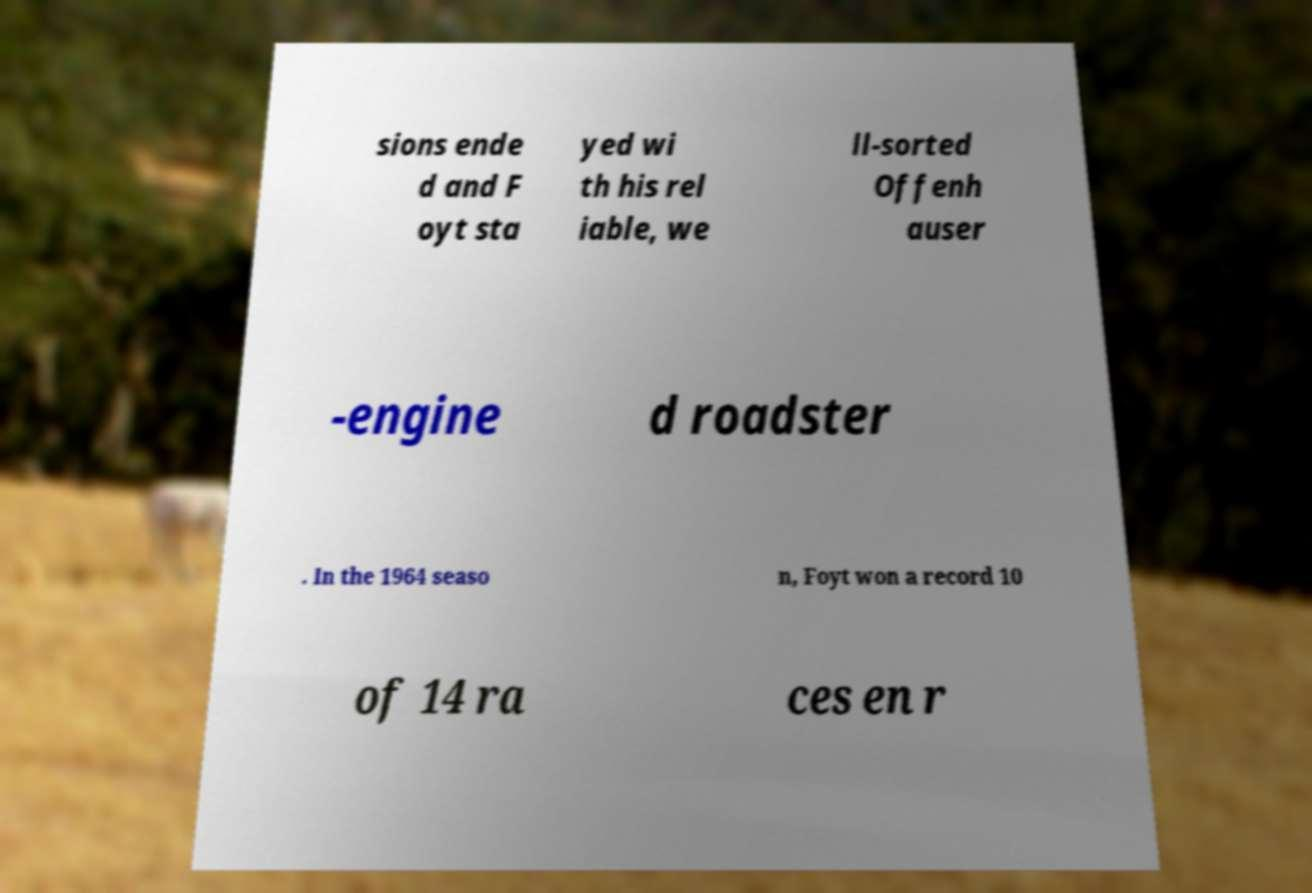Please read and relay the text visible in this image. What does it say? sions ende d and F oyt sta yed wi th his rel iable, we ll-sorted Offenh auser -engine d roadster . In the 1964 seaso n, Foyt won a record 10 of 14 ra ces en r 